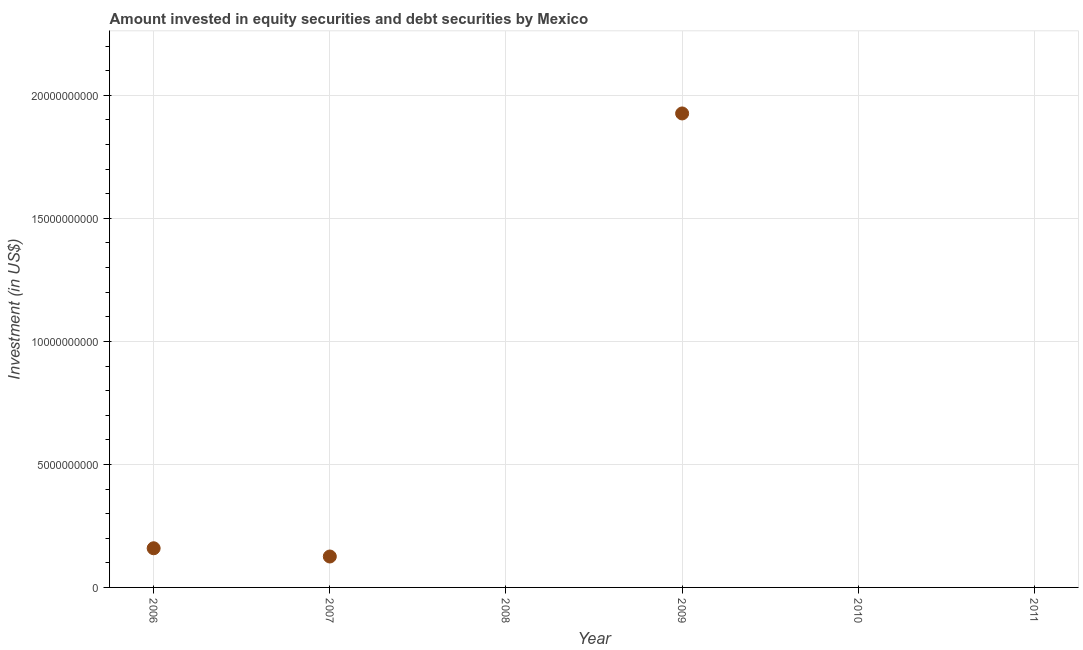What is the portfolio investment in 2008?
Your response must be concise. 0. Across all years, what is the maximum portfolio investment?
Offer a terse response. 1.93e+1. What is the sum of the portfolio investment?
Keep it short and to the point. 2.21e+1. What is the difference between the portfolio investment in 2006 and 2009?
Ensure brevity in your answer.  -1.77e+1. What is the average portfolio investment per year?
Your response must be concise. 3.69e+09. What is the median portfolio investment?
Your answer should be very brief. 6.28e+08. What is the ratio of the portfolio investment in 2007 to that in 2009?
Offer a terse response. 0.07. Is the difference between the portfolio investment in 2006 and 2009 greater than the difference between any two years?
Offer a terse response. No. What is the difference between the highest and the second highest portfolio investment?
Your response must be concise. 1.77e+1. Is the sum of the portfolio investment in 2007 and 2009 greater than the maximum portfolio investment across all years?
Keep it short and to the point. Yes. What is the difference between the highest and the lowest portfolio investment?
Your answer should be compact. 1.93e+1. Does the portfolio investment monotonically increase over the years?
Offer a very short reply. No. How many dotlines are there?
Provide a short and direct response. 1. What is the difference between two consecutive major ticks on the Y-axis?
Provide a short and direct response. 5.00e+09. What is the title of the graph?
Your answer should be compact. Amount invested in equity securities and debt securities by Mexico. What is the label or title of the X-axis?
Ensure brevity in your answer.  Year. What is the label or title of the Y-axis?
Offer a very short reply. Investment (in US$). What is the Investment (in US$) in 2006?
Provide a succinct answer. 1.59e+09. What is the Investment (in US$) in 2007?
Make the answer very short. 1.26e+09. What is the Investment (in US$) in 2009?
Give a very brief answer. 1.93e+1. What is the difference between the Investment (in US$) in 2006 and 2007?
Offer a terse response. 3.35e+08. What is the difference between the Investment (in US$) in 2006 and 2009?
Provide a succinct answer. -1.77e+1. What is the difference between the Investment (in US$) in 2007 and 2009?
Provide a short and direct response. -1.80e+1. What is the ratio of the Investment (in US$) in 2006 to that in 2007?
Give a very brief answer. 1.27. What is the ratio of the Investment (in US$) in 2006 to that in 2009?
Make the answer very short. 0.08. What is the ratio of the Investment (in US$) in 2007 to that in 2009?
Your response must be concise. 0.07. 